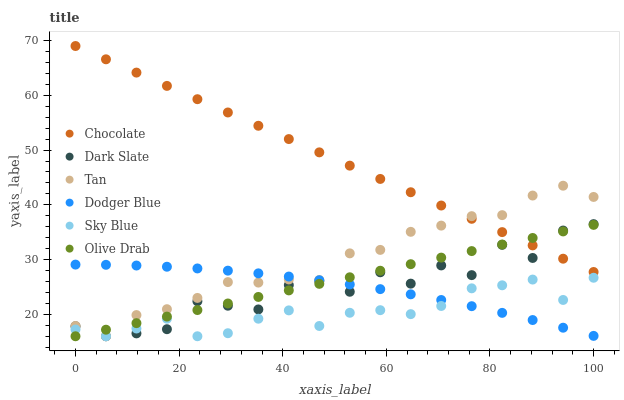Does Sky Blue have the minimum area under the curve?
Answer yes or no. Yes. Does Chocolate have the maximum area under the curve?
Answer yes or no. Yes. Does Dark Slate have the minimum area under the curve?
Answer yes or no. No. Does Dark Slate have the maximum area under the curve?
Answer yes or no. No. Is Olive Drab the smoothest?
Answer yes or no. Yes. Is Dark Slate the roughest?
Answer yes or no. Yes. Is Dodger Blue the smoothest?
Answer yes or no. No. Is Dodger Blue the roughest?
Answer yes or no. No. Does Dark Slate have the lowest value?
Answer yes or no. Yes. Does Dodger Blue have the lowest value?
Answer yes or no. No. Does Chocolate have the highest value?
Answer yes or no. Yes. Does Dark Slate have the highest value?
Answer yes or no. No. Is Sky Blue less than Chocolate?
Answer yes or no. Yes. Is Chocolate greater than Sky Blue?
Answer yes or no. Yes. Does Sky Blue intersect Dark Slate?
Answer yes or no. Yes. Is Sky Blue less than Dark Slate?
Answer yes or no. No. Is Sky Blue greater than Dark Slate?
Answer yes or no. No. Does Sky Blue intersect Chocolate?
Answer yes or no. No. 